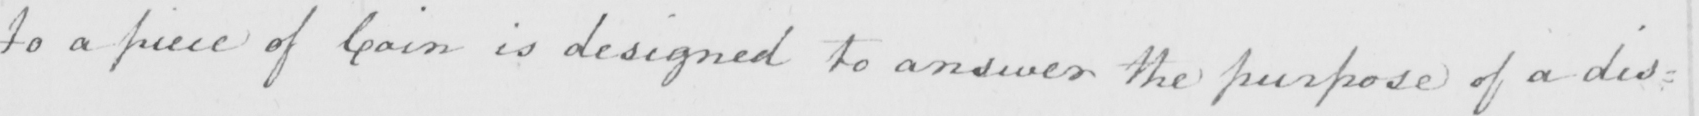Please provide the text content of this handwritten line. to a piece of coin is designed to answer the purpose of a dis= 